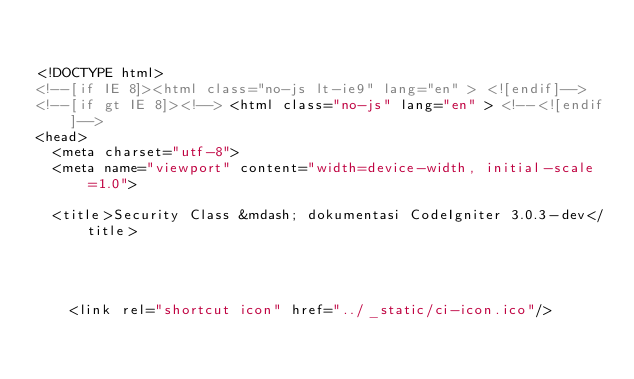<code> <loc_0><loc_0><loc_500><loc_500><_HTML_>

<!DOCTYPE html>
<!--[if IE 8]><html class="no-js lt-ie9" lang="en" > <![endif]-->
<!--[if gt IE 8]><!--> <html class="no-js" lang="en" > <!--<![endif]-->
<head>
  <meta charset="utf-8">
  <meta name="viewport" content="width=device-width, initial-scale=1.0">
  
  <title>Security Class &mdash; dokumentasi CodeIgniter 3.0.3-dev</title>
  

  
  
    <link rel="shortcut icon" href="../_static/ci-icon.ico"/>
  

  </code> 